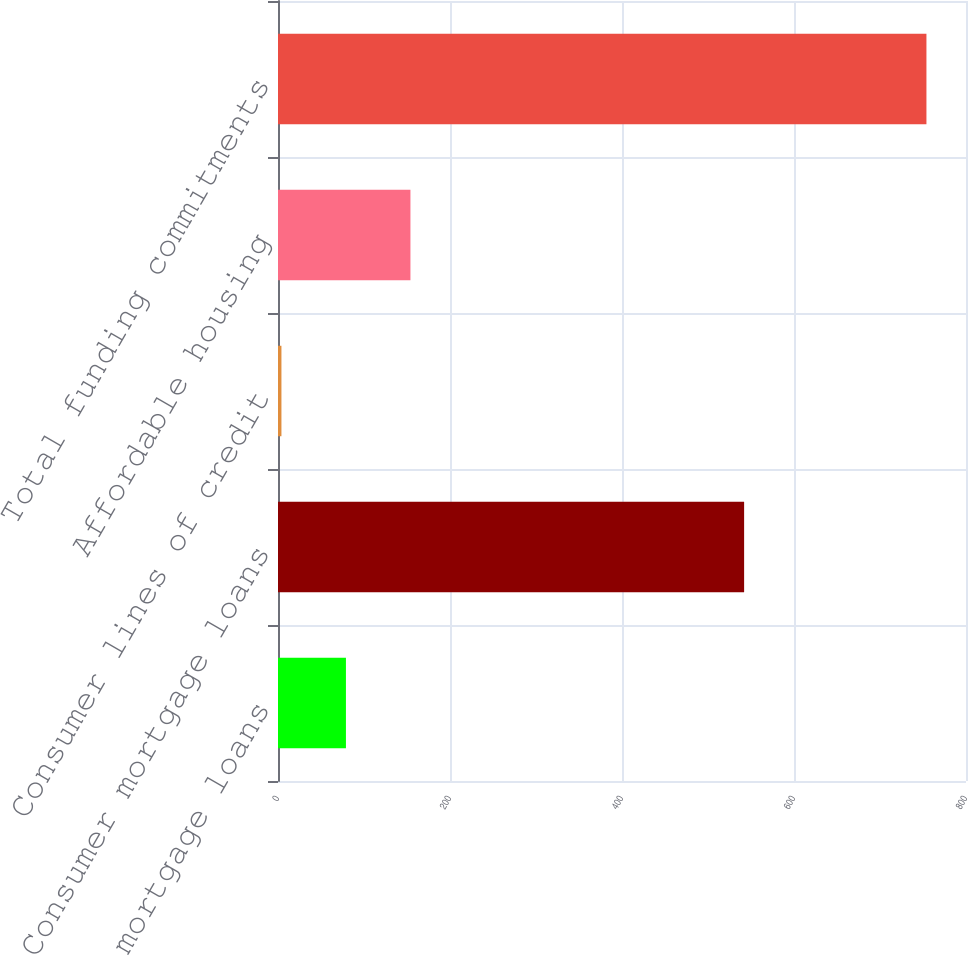<chart> <loc_0><loc_0><loc_500><loc_500><bar_chart><fcel>Commercial mortgage loans<fcel>Consumer mortgage loans<fcel>Consumer lines of credit<fcel>Affordable housing<fcel>Total funding commitments<nl><fcel>79<fcel>542<fcel>4<fcel>154<fcel>754<nl></chart> 